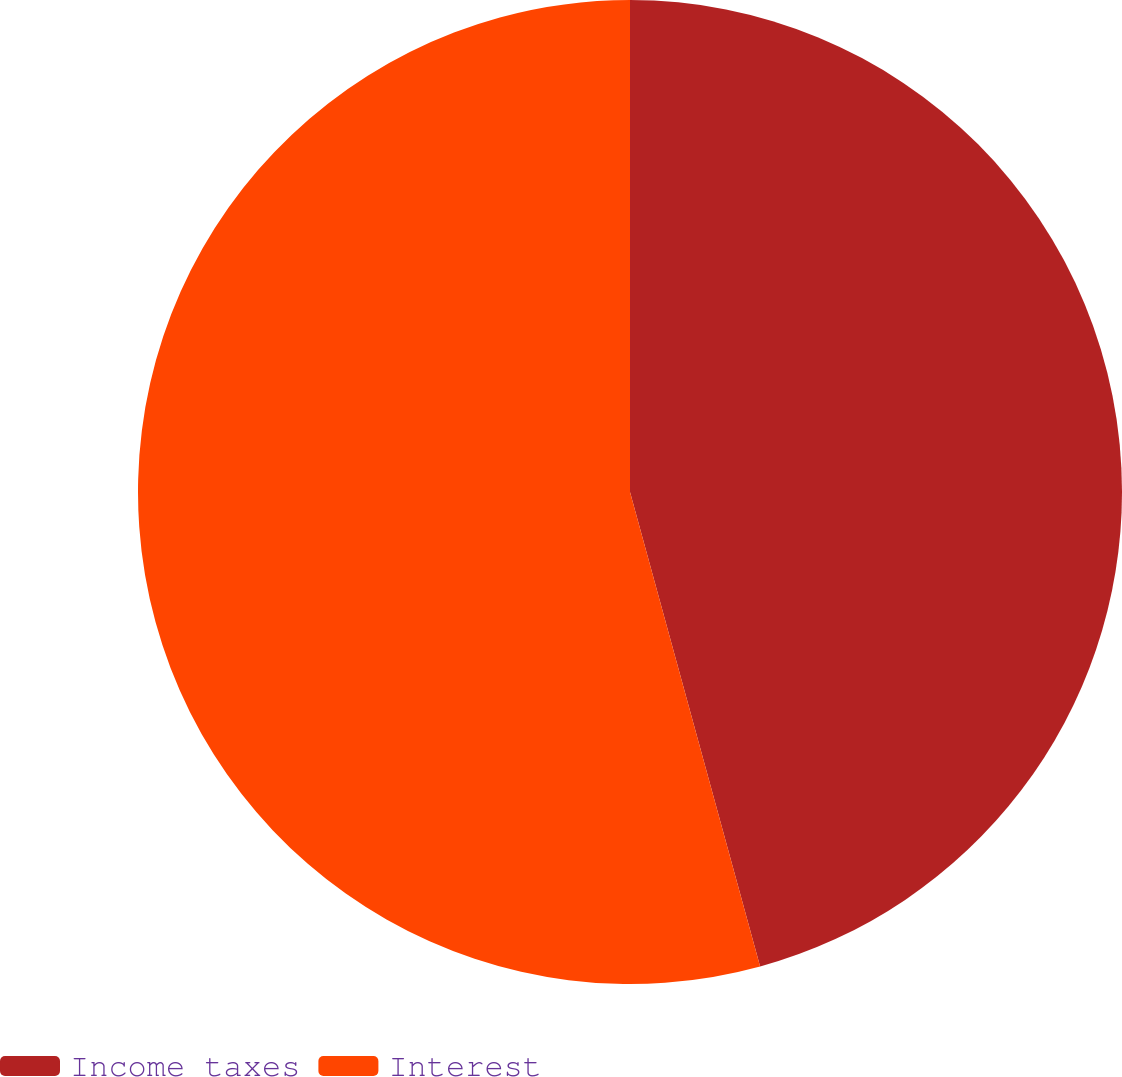Convert chart. <chart><loc_0><loc_0><loc_500><loc_500><pie_chart><fcel>Income taxes<fcel>Interest<nl><fcel>45.74%<fcel>54.26%<nl></chart> 